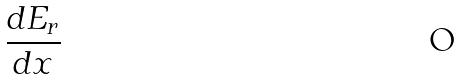<formula> <loc_0><loc_0><loc_500><loc_500>\frac { d E _ { r } } { d x }</formula> 